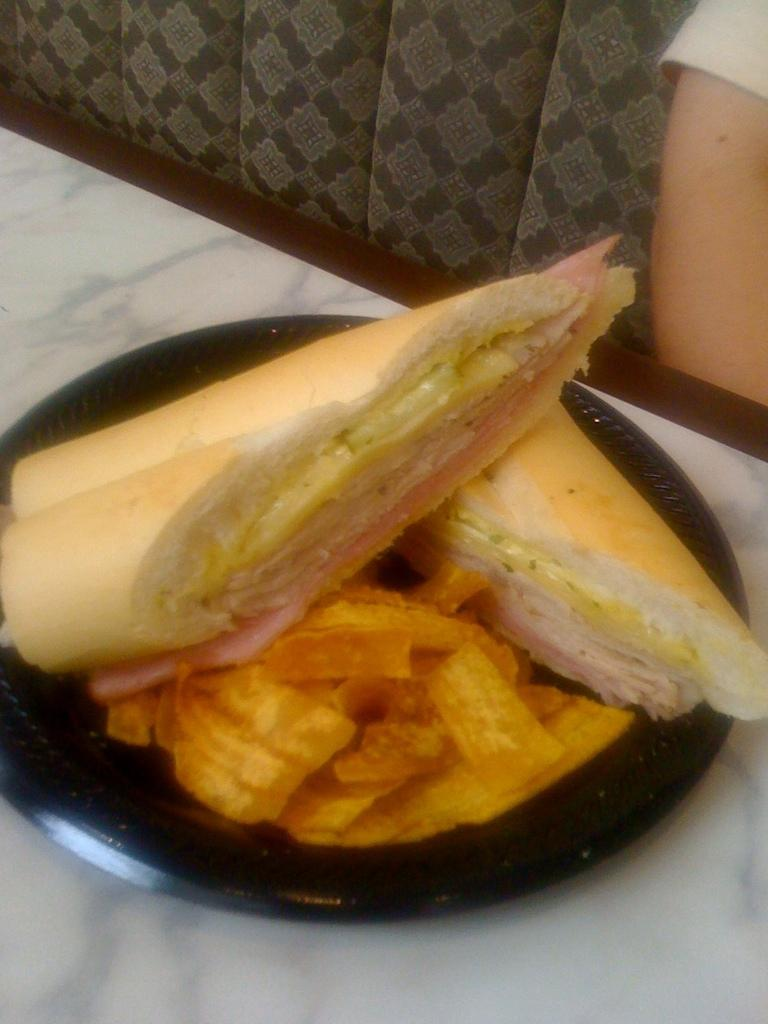What is on the tray in the image? There is a food item in a tray in the image. Where is the tray located? The tray is on top of a table in the image. What can be seen in front of the table? There is a person sitting on a sofa in front of the table. What scientific discoveries does the governor make while sitting on the sofa in the image? There is no governor or scientific discoveries mentioned in the image. The image only shows a food item in a tray on a table and a person sitting on a sofa in front of the table. 